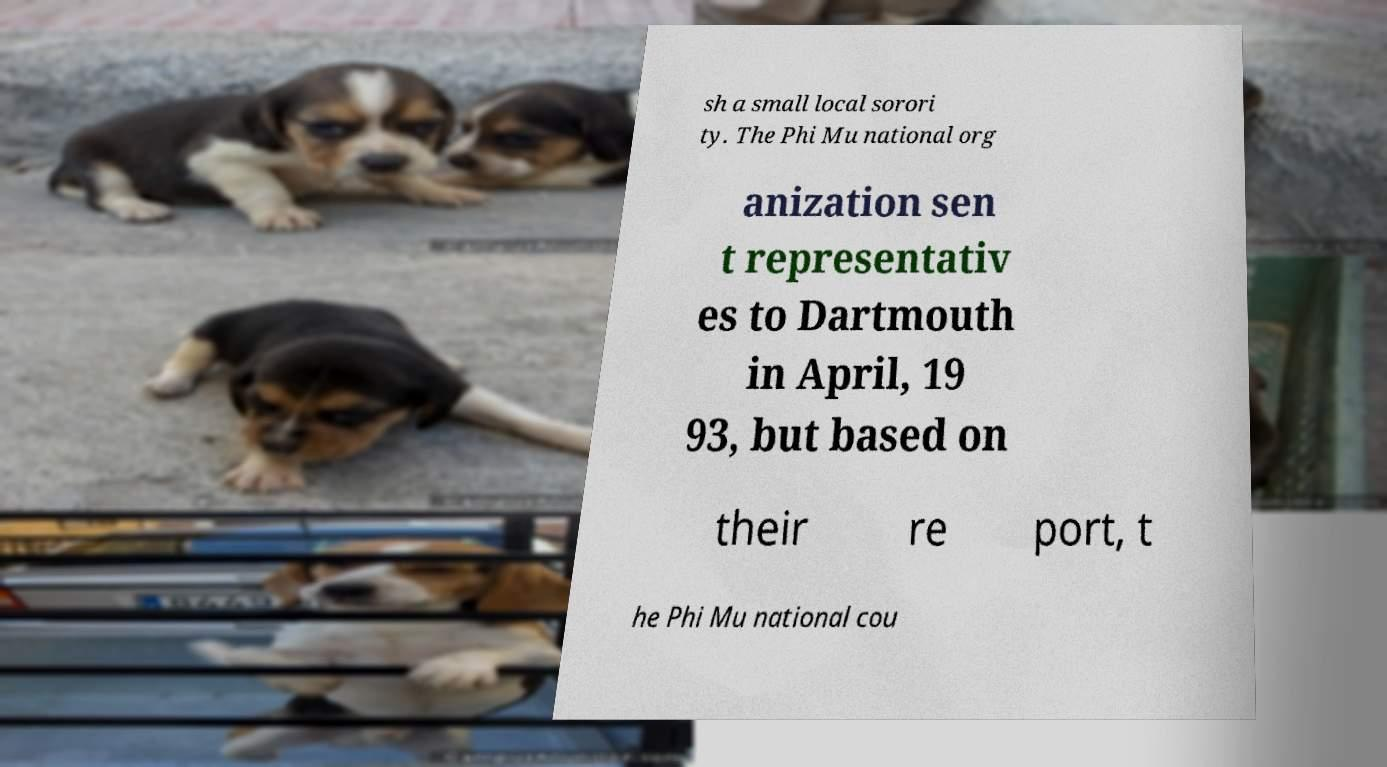What messages or text are displayed in this image? I need them in a readable, typed format. sh a small local sorori ty. The Phi Mu national org anization sen t representativ es to Dartmouth in April, 19 93, but based on their re port, t he Phi Mu national cou 